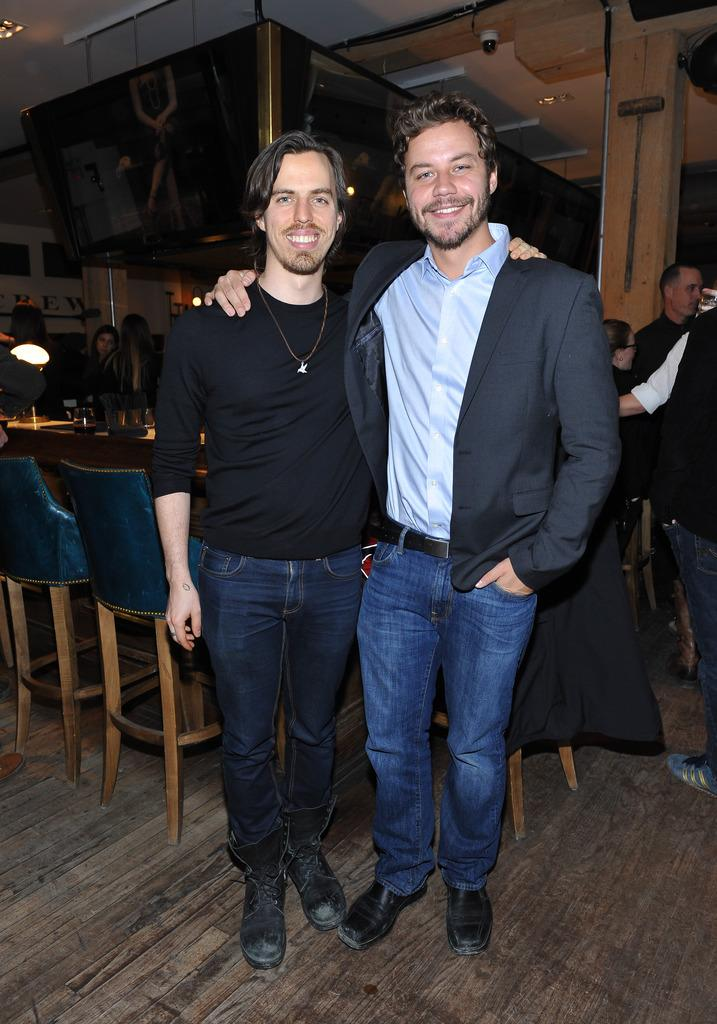How many boys are in the image? There are two boys in the image. What are the boys doing in the image? The boys are standing together. What color are the coats or T-shirts worn by the boys? The boys are wearing black color coats or T-shirts. What can be seen in the background of the image? There is a dining table and a woman in the background of the image. What type of camera can be seen in the hands of one of the boys? There is no camera present in the image; the boys are not holding any cameras. 